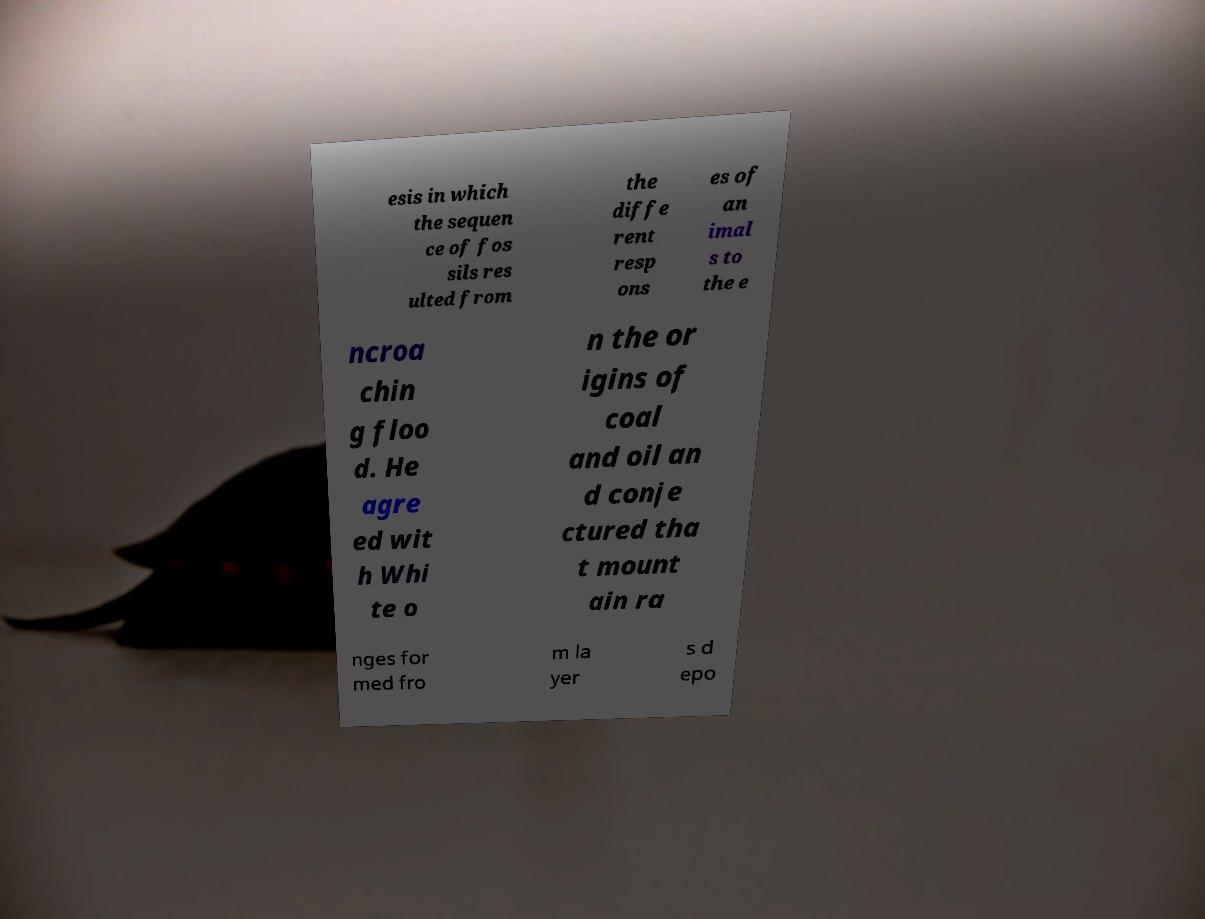I need the written content from this picture converted into text. Can you do that? esis in which the sequen ce of fos sils res ulted from the diffe rent resp ons es of an imal s to the e ncroa chin g floo d. He agre ed wit h Whi te o n the or igins of coal and oil an d conje ctured tha t mount ain ra nges for med fro m la yer s d epo 